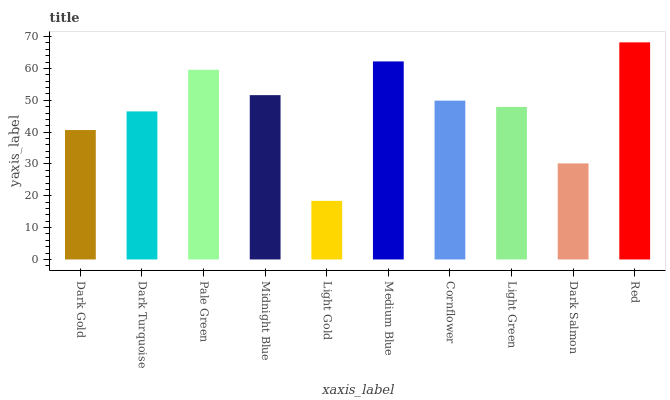Is Light Gold the minimum?
Answer yes or no. Yes. Is Red the maximum?
Answer yes or no. Yes. Is Dark Turquoise the minimum?
Answer yes or no. No. Is Dark Turquoise the maximum?
Answer yes or no. No. Is Dark Turquoise greater than Dark Gold?
Answer yes or no. Yes. Is Dark Gold less than Dark Turquoise?
Answer yes or no. Yes. Is Dark Gold greater than Dark Turquoise?
Answer yes or no. No. Is Dark Turquoise less than Dark Gold?
Answer yes or no. No. Is Cornflower the high median?
Answer yes or no. Yes. Is Light Green the low median?
Answer yes or no. Yes. Is Red the high median?
Answer yes or no. No. Is Red the low median?
Answer yes or no. No. 